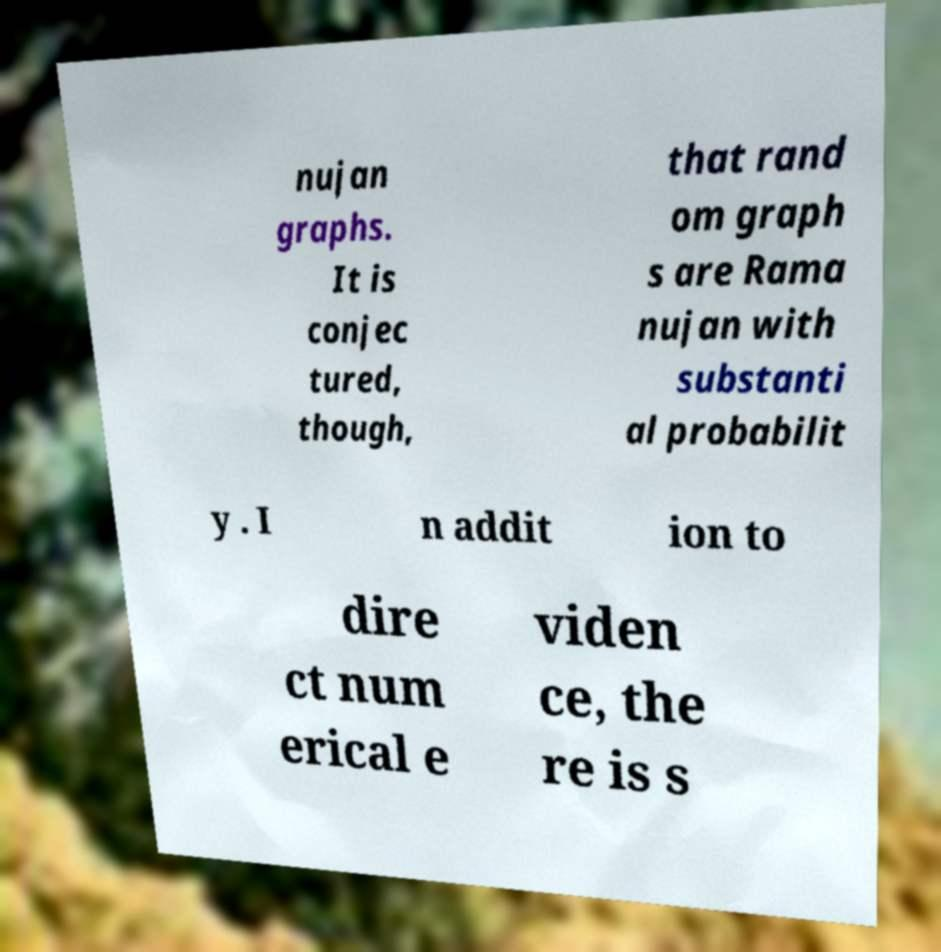Can you read and provide the text displayed in the image?This photo seems to have some interesting text. Can you extract and type it out for me? nujan graphs. It is conjec tured, though, that rand om graph s are Rama nujan with substanti al probabilit y . I n addit ion to dire ct num erical e viden ce, the re is s 